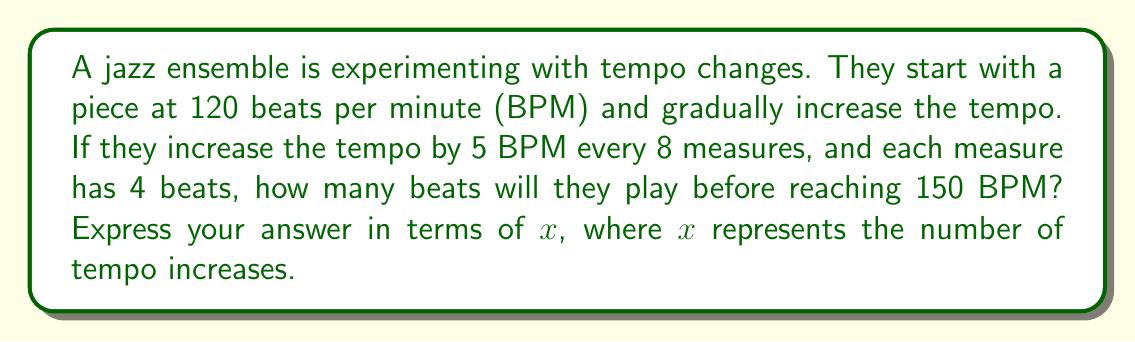Could you help me with this problem? Let's approach this step-by-step:

1) First, let's set up an equation for the final tempo:
   $120 + 5x = 150$, where $x$ is the number of tempo increases

2) Solve for $x$:
   $5x = 30$
   $x = 6$

3) Now we know it takes 6 tempo increases to reach 150 BPM.

4) Each tempo increase happens every 8 measures.
   Total measures = $8x = 8(6) = 48$ measures

5) Each measure has 4 beats.
   Total beats = $48 * 4 = 192$ beats

6) However, we need to express this in terms of $x$.
   Total beats = $8x * 4 = 32x$ beats

Therefore, the algebraic expression for the total number of beats is $32x$.
Answer: $32x$ beats 